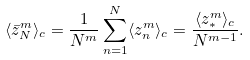<formula> <loc_0><loc_0><loc_500><loc_500>\langle \bar { z } _ { N } ^ { m } \rangle _ { c } = \frac { 1 } { N ^ { m } } \sum _ { n = 1 } ^ { N } \langle z _ { n } ^ { m } \rangle _ { c } = \frac { \langle z _ { \ast } ^ { m } \rangle _ { c } } { N ^ { m - 1 } } .</formula> 